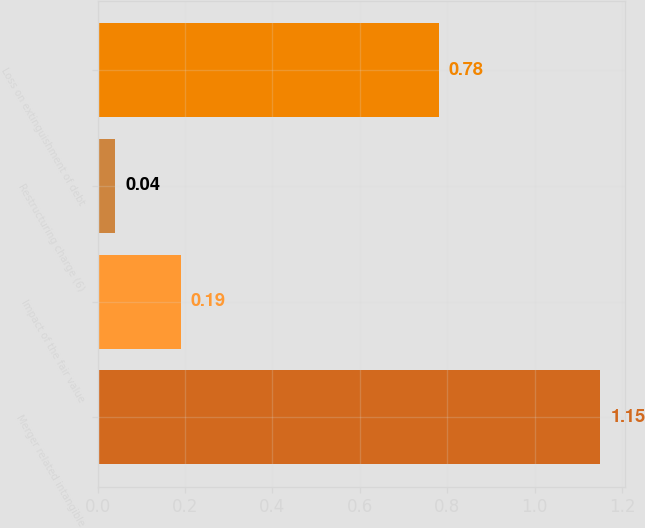<chart> <loc_0><loc_0><loc_500><loc_500><bar_chart><fcel>Merger related intangible<fcel>Impact of the fair value<fcel>Restructuring charge (6)<fcel>Loss on extinguishment of debt<nl><fcel>1.15<fcel>0.19<fcel>0.04<fcel>0.78<nl></chart> 